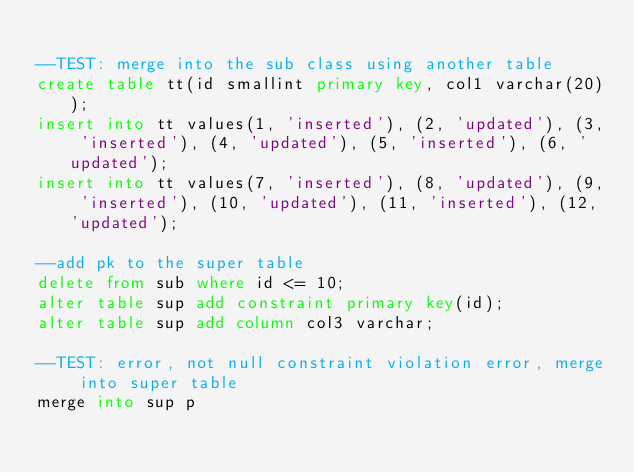<code> <loc_0><loc_0><loc_500><loc_500><_SQL_>
--TEST: merge into the sub class using another table
create table tt(id smallint primary key, col1 varchar(20));
insert into tt values(1, 'inserted'), (2, 'updated'), (3, 'inserted'), (4, 'updated'), (5, 'inserted'), (6, 'updated');
insert into tt values(7, 'inserted'), (8, 'updated'), (9, 'inserted'), (10, 'updated'), (11, 'inserted'), (12, 'updated');

--add pk to the super table
delete from sub where id <= 10;
alter table sup add constraint primary key(id);
alter table sup add column col3 varchar;

--TEST: error, not null constraint violation error, merge into super table
merge into sup p</code> 